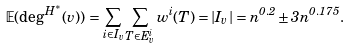<formula> <loc_0><loc_0><loc_500><loc_500>\mathbb { E } ( \deg ^ { H ^ { \ast } } ( v ) ) = \sum _ { i \in I _ { v } } \sum _ { T \in E ^ { i } _ { v } } w ^ { i } ( T ) = | I _ { v } | = n ^ { 0 . 2 } \pm 3 n ^ { 0 . 1 7 5 } .</formula> 